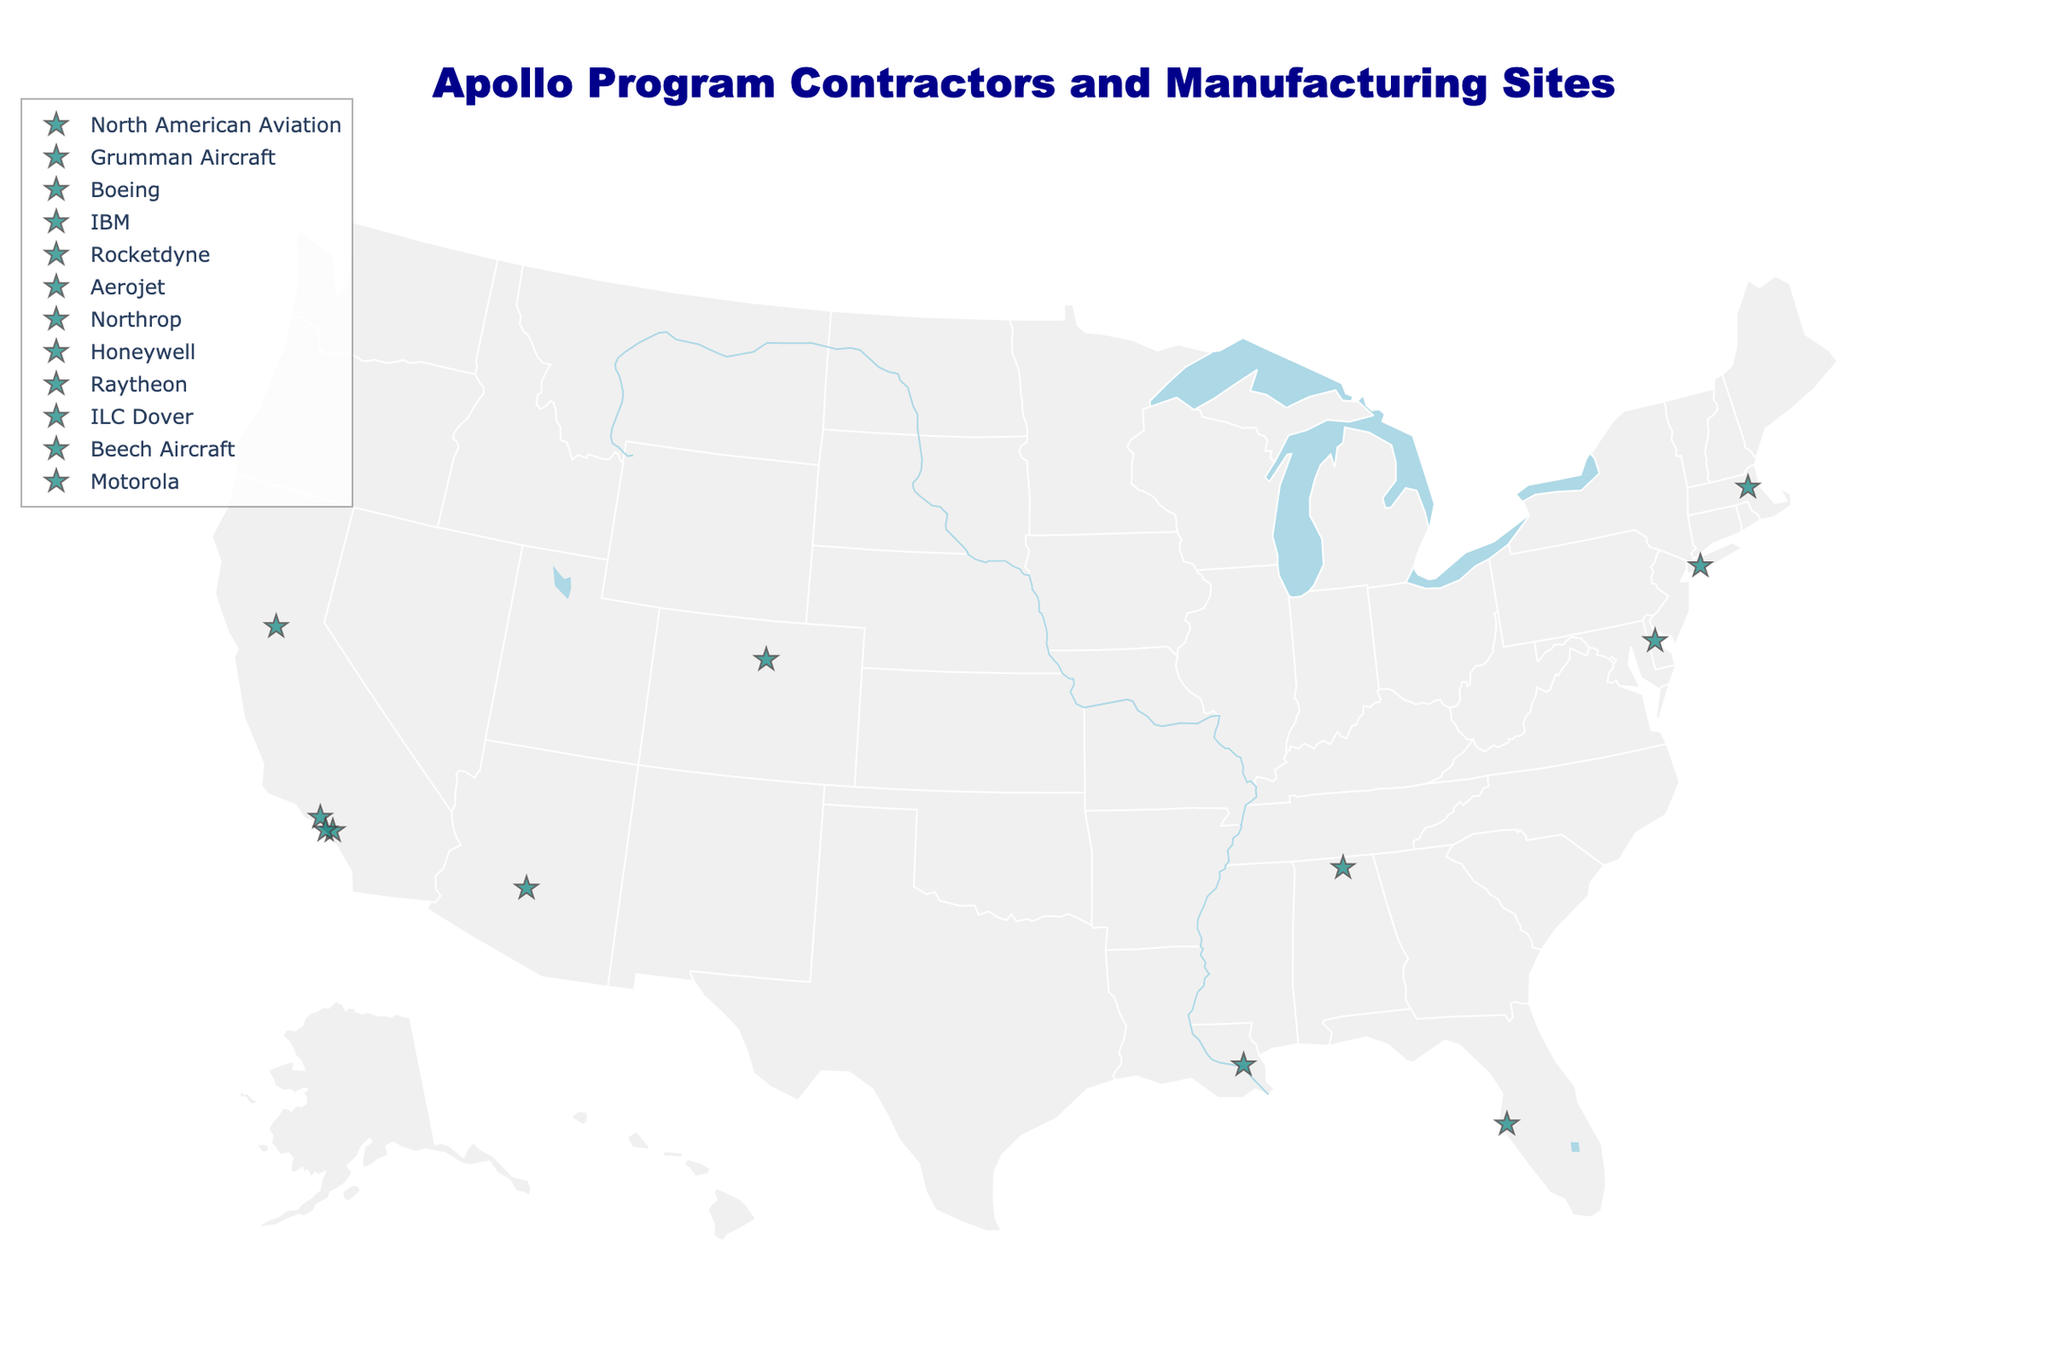What's the title of the figure? The title is usually at the top-center of the figure. Looking at the visual, the title reads "Apollo Program Contractors and Manufacturing Sites".
Answer: Apollo Program Contractors and Manufacturing Sites How many contractors are represented in the figure? Each marker on the map represents a different contractor. Counting the distinct markers and their labels will give us the number of contractors.
Answer: 12 Which contractor is located furthest west? To find the westernmost contractor, we look at the markers on the leftmost (western) side of the map. The contractor in Scottsdale, Arizona (Motorola) and multiple in California are candidates. By checking the longitude, Motorola is the furthest west.
Answer: Motorola Which component was manufactured by Honeywell, and where is it located? The markers have labels that show the contractor's name and the component they produced. Find Honeywell's marker to see the component and location. Honeywell produced guidance and navigation systems in St. Petersburg, Florida.
Answer: Guidance and navigation systems, St. Petersburg, Florida Which two states have the highest number of contractor sites? By visually scanning the figure, tally the markers per state. California appears frequently and should be counted. Then, New York is also notable. However, California (Downey, Canoga Park, Sacramento, Hawthorne) has the highest with four sites rather than two different states equally prevalent.
Answer: California and California again Which contractor worked on the Lunar Module descent engine? Each marker has a label that includes the contractor and the component they made. By finding the label for "Lunar Module descent engine", we see it was produced by Northrop.
Answer: Northrop What is the average latitude of all locations in California? To calculate the average latitude, sum all latitudes for the California locations (33.9402, 34.2011, 38.5816, 33.9164) and divide by the number of locations (4). (33.9402 + 34.2011 + 38.5816 + 33.9164) / 4 = 35.159825.
Answer: 35.16 Which contractor is located closest to the easternmost point on the map? Identify the easternmost (rightmost) point by examining the map. Waltham, Massachusetts where Raytheon is, is furthest east.
Answer: Raytheon Which component had its manufacturing site located in Delaware? By examining the map and the labels, we find ILC Dover in Dover, Delaware, which produced spacesuits.
Answer: Spacesuits How many unique components are listed in the figure? Each marker shows a specific component. Count the distinct component names, ensuring no duplicates. There are 12: Command Module, Lunar Module, Saturn V first stage, Saturn V guidance computer, F-1 engines, Service Module engine, Lunar Module descent engine, Guidance and navigation systems, Apollo Guidance Computer, Spacesuits, Cryogenic storage tanks, Communications equipment.
Answer: 12 